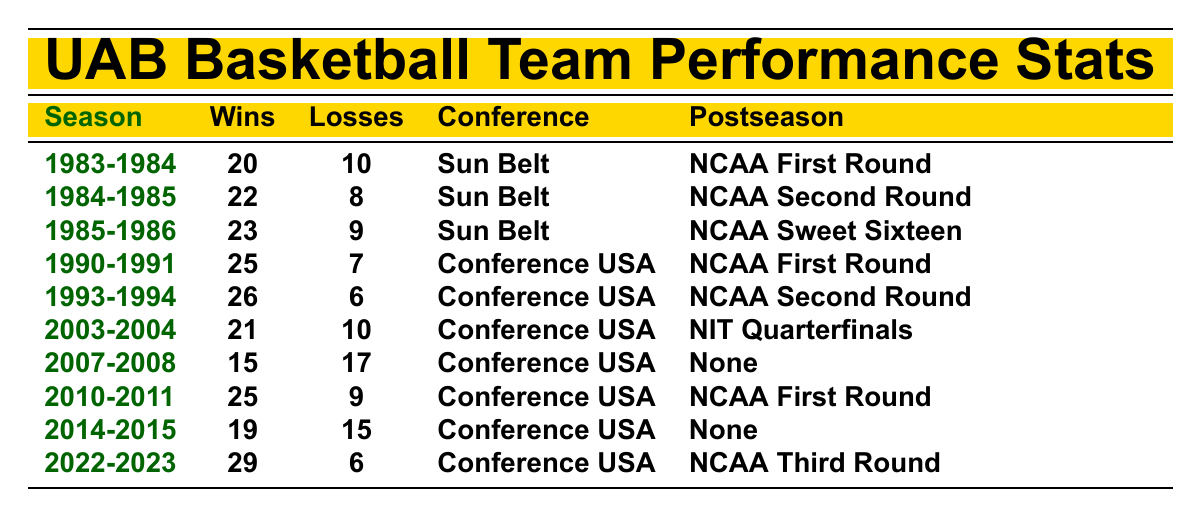What was the UAB basketball team's win-loss record in the 1985-1986 season? The table indicates that in the 1985-1986 season, UAB had 23 wins and 9 losses.
Answer: 23 wins and 9 losses How many seasons did UAB basketball participate in the NCAA tournament from 1983 to 2023? A review of the postseason column shows that UAB participated in the NCAA tournament during the seasons 1983-1984, 1984-1985, 1985-1986, 1990-1991, 1993-1994, 2010-2011, and 2022-2023, totaling 7 seasons.
Answer: 7 seasons What was the total number of wins for UAB basketball from 1983 to 2023? Adding the wins from each season: 20 + 22 + 23 + 25 + 26 + 21 + 15 + 25 + 19 + 29 =  205.
Answer: 205 During which season did UAB achieve the highest number of wins, and how many were there? By checking the wins in the table, the highest number of wins is 29 during the 2022-2023 season.
Answer: 2022-2023 season with 29 wins Did UAB have any seasons with a losing record? Looking at the losses column, the only season with more losses than wins is 2007-2008, with 15 wins and 17 losses, indicating a losing record.
Answer: Yes What was the average number of wins per season over the entire dataset? To find the average, sum the total wins (205) and divide by the number of seasons (10): 205/10 = 20.5.
Answer: 20.5 wins Which season had the most losses and what was the number of losses? The table shows that the season with the most losses is 2007-2008, with 17 losses.
Answer: 2007-2008 season with 17 losses Was there a season in which UAB made it to the Sweet Sixteen? The postseason column indicates that UAB reached the Sweet Sixteen in the 1985-1986 season.
Answer: Yes, in 1985-1986 What is the difference in wins between the 1993-1994 season and the 2014-2015 season? The 1993-1994 season had 26 wins, and the 2014-2015 season had 19 wins. The difference is 26 - 19 = 7.
Answer: 7 wins How many times did UAB not participate in any postseason during the observed seasons? From the postseason column, there are two instances where UAB had no postseason: in 2007-2008 and 2014-2015.
Answer: 2 times 